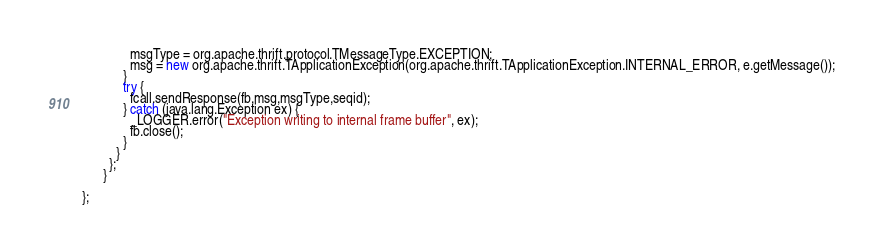<code> <loc_0><loc_0><loc_500><loc_500><_Java_>              msgType = org.apache.thrift.protocol.TMessageType.EXCEPTION;
              msg = new org.apache.thrift.TApplicationException(org.apache.thrift.TApplicationException.INTERNAL_ERROR, e.getMessage());
            }
            try {
              fcall.sendResponse(fb,msg,msgType,seqid);
            } catch (java.lang.Exception ex) {
              _LOGGER.error("Exception writing to internal frame buffer", ex);
              fb.close();
            }
          }
        };
      }

};</code> 